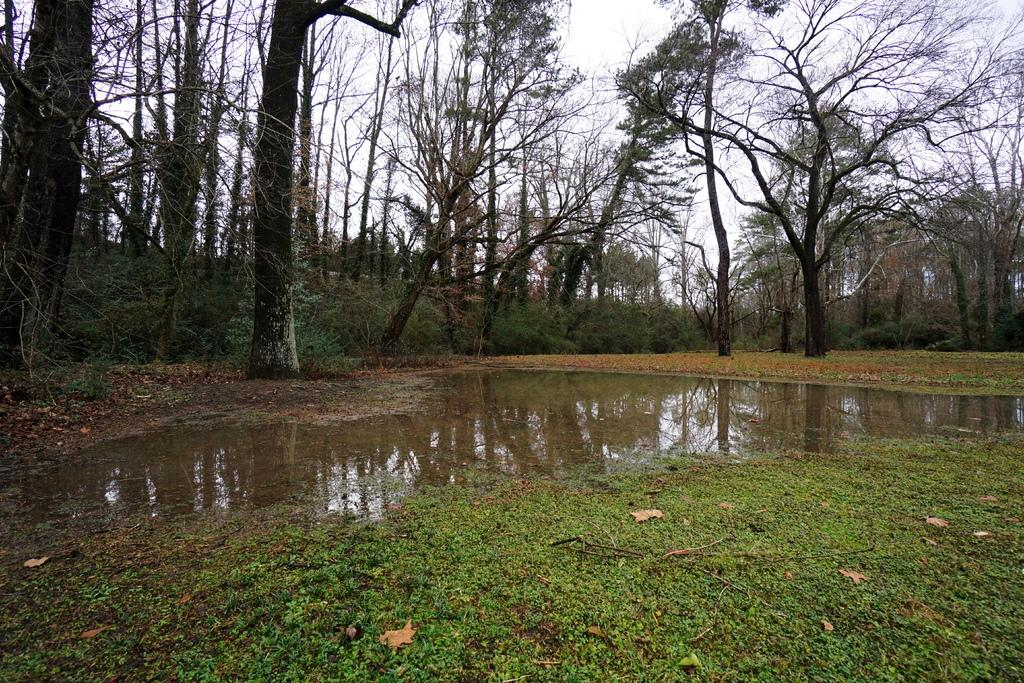What type of environment is depicted in the image? The image is an outside view. What can be seen on the ground in the image? There is water on the ground in the image. What type of vegetation is visible in the image? There is grass visible in the image. What is visible in the background of the image? There are trees in the background of the image. What is visible at the top of the image? The sky is visible at the top of the image. How many pies are being held by the women in the image? There are no women or pies present in the image. What type of beetle can be seen crawling on the grass in the image? There is no beetle visible in the image; only water, grass, trees, and the sky are present. 